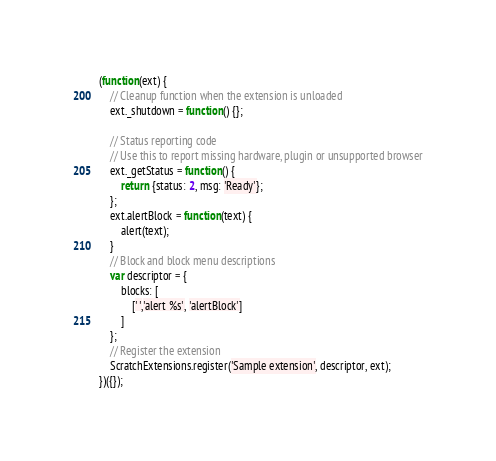<code> <loc_0><loc_0><loc_500><loc_500><_JavaScript_>(function(ext) {
    // Cleanup function when the extension is unloaded
    ext._shutdown = function() {};

    // Status reporting code
    // Use this to report missing hardware, plugin or unsupported browser
    ext._getStatus = function() {
        return {status: 2, msg: 'Ready'};
    };
    ext.alertBlock = function(text) {
        alert(text);
    }
    // Block and block menu descriptions
    var descriptor = {
        blocks: [
            [' ','alert %s', 'alertBlock']
        ]
    };
    // Register the extension
    ScratchExtensions.register('Sample extension', descriptor, ext);
})({});</code> 